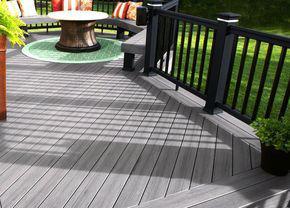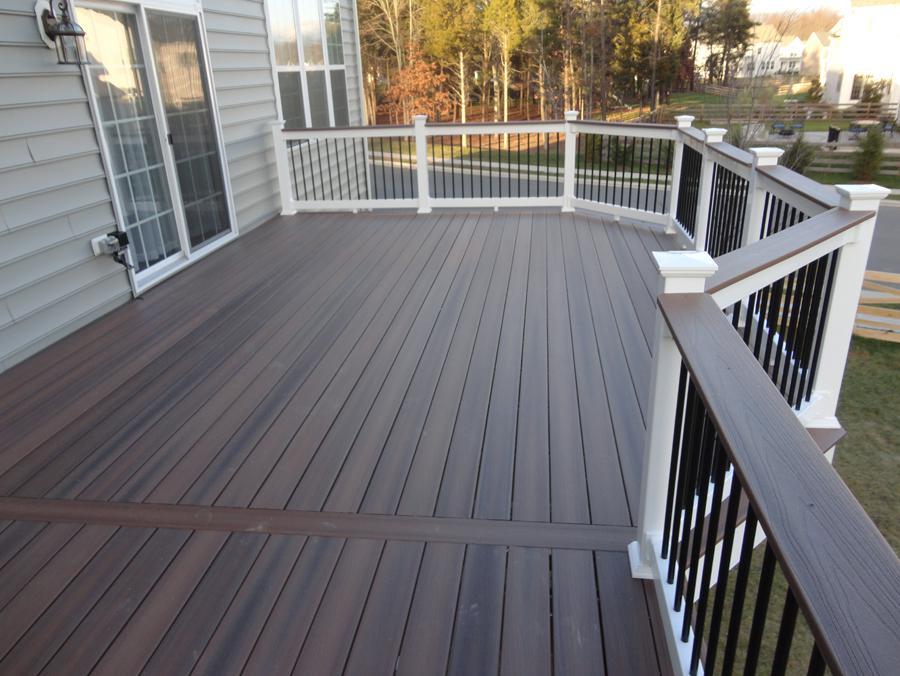The first image is the image on the left, the second image is the image on the right. Assess this claim about the two images: "One of the railings has white main posts with smaller black posts in between.". Correct or not? Answer yes or no. Yes. The first image is the image on the left, the second image is the image on the right. For the images shown, is this caption "The right image shows a deck with a jutting section instead of a straight across front, and white corner posts with dark brown flat boards atop the handrails." true? Answer yes or no. Yes. 